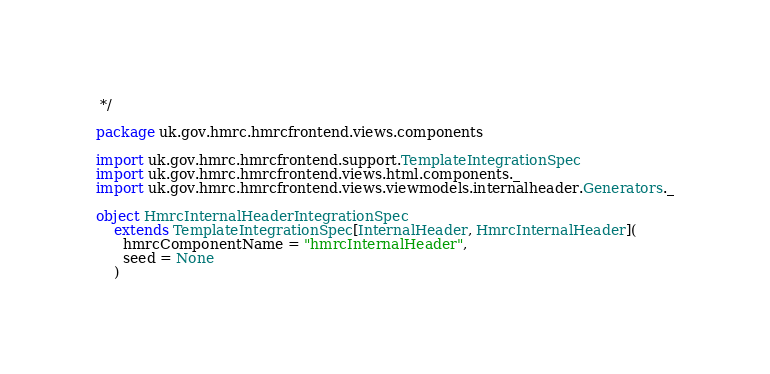<code> <loc_0><loc_0><loc_500><loc_500><_Scala_> */

package uk.gov.hmrc.hmrcfrontend.views.components

import uk.gov.hmrc.hmrcfrontend.support.TemplateIntegrationSpec
import uk.gov.hmrc.hmrcfrontend.views.html.components._
import uk.gov.hmrc.hmrcfrontend.views.viewmodels.internalheader.Generators._

object HmrcInternalHeaderIntegrationSpec
    extends TemplateIntegrationSpec[InternalHeader, HmrcInternalHeader](
      hmrcComponentName = "hmrcInternalHeader",
      seed = None
    )
</code> 